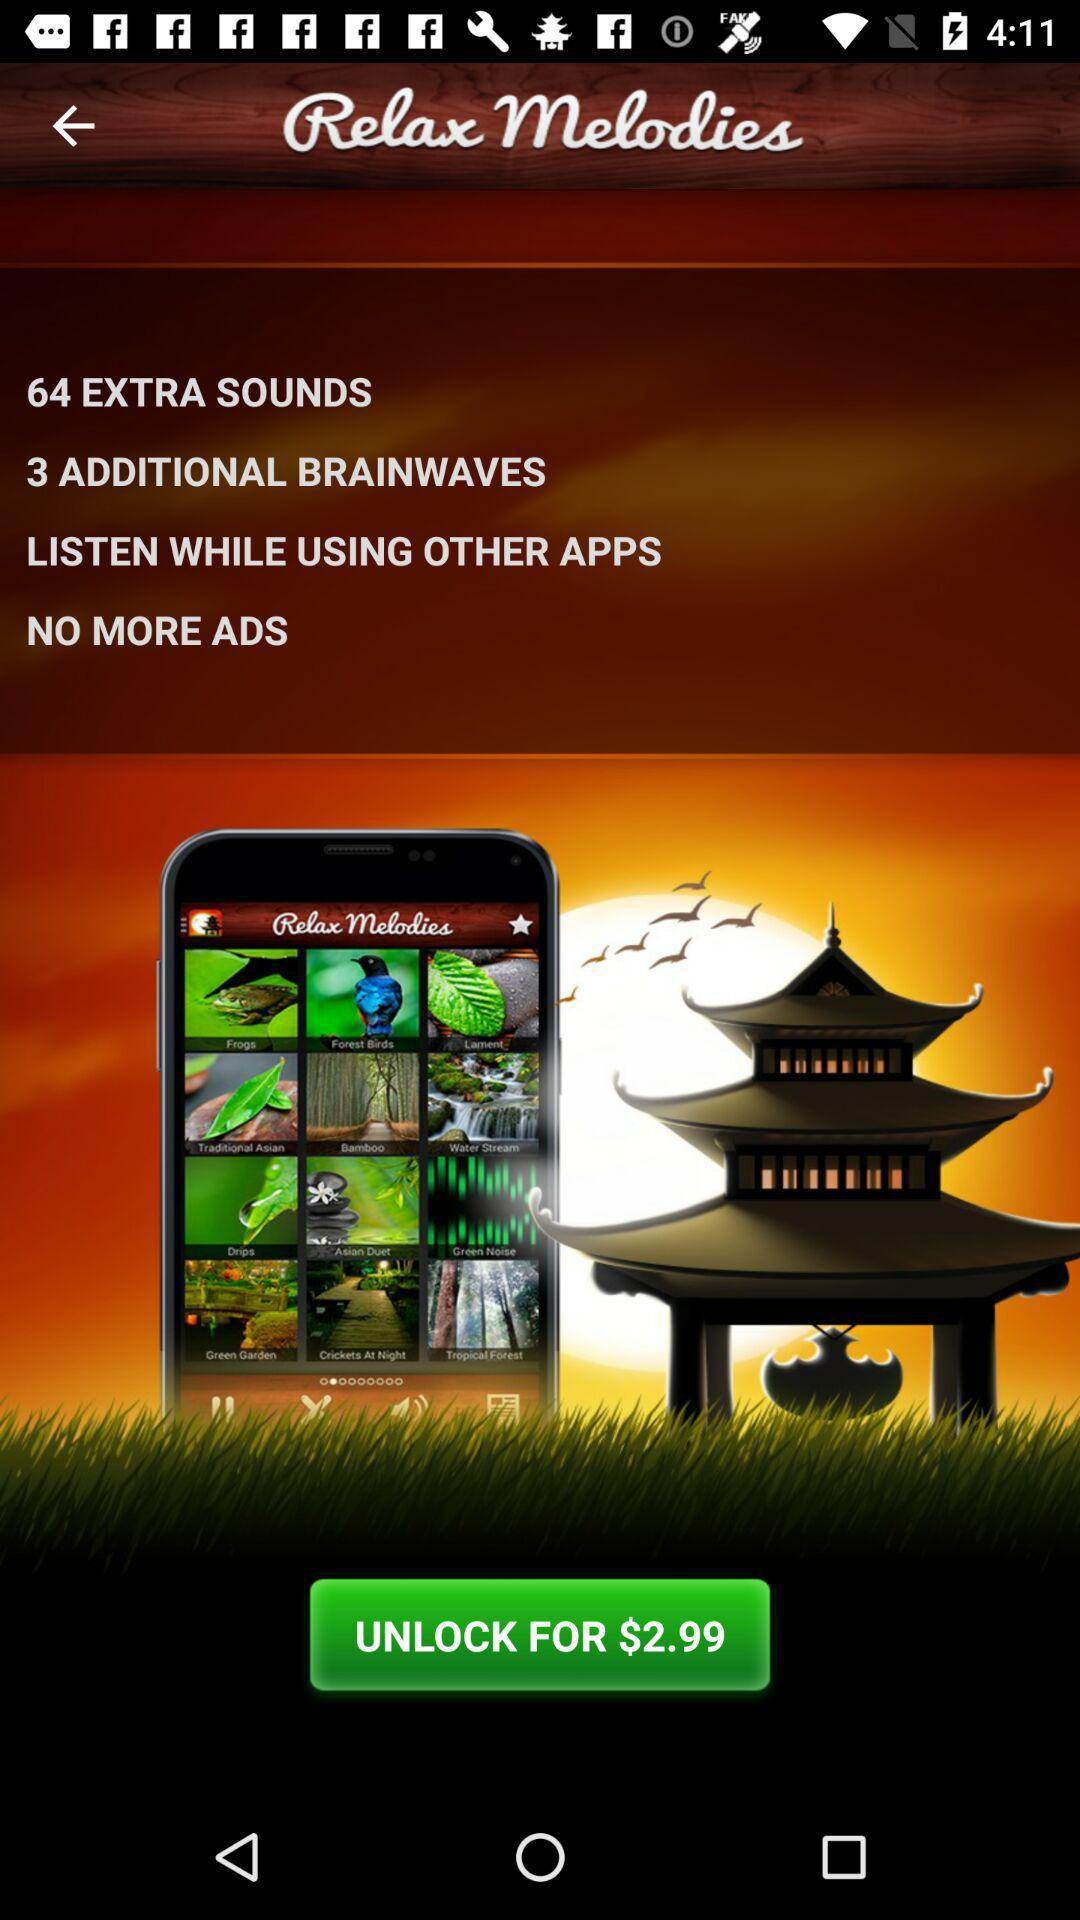How many extra sounds are there? There are 64 extra sounds. 